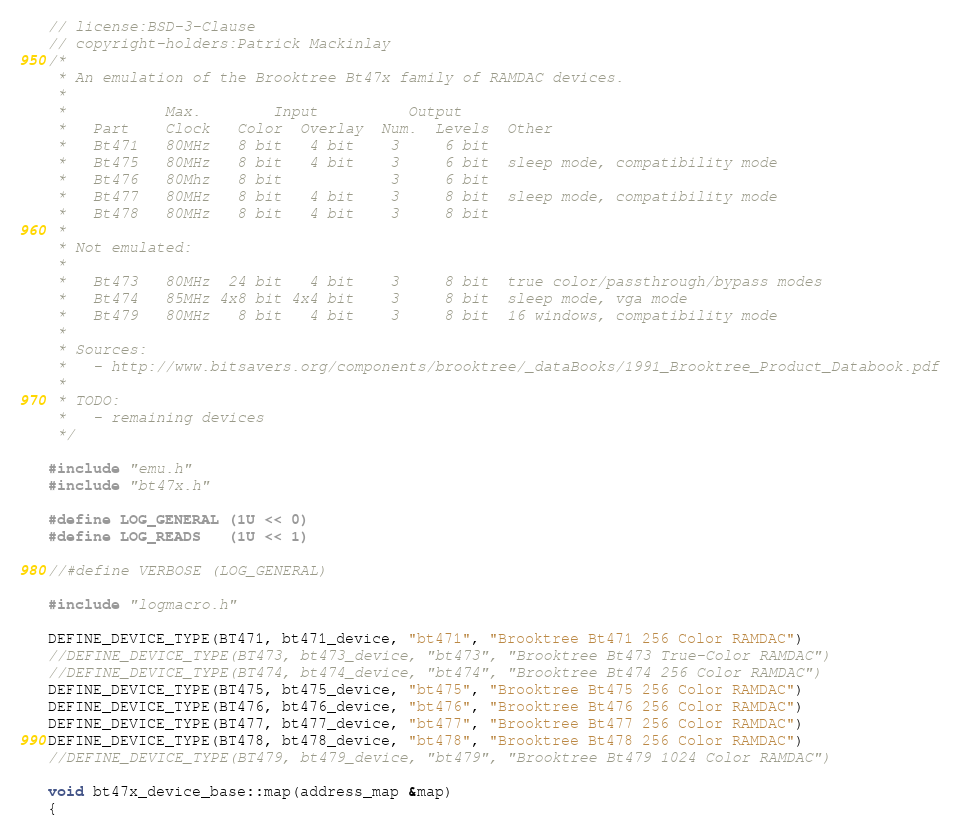<code> <loc_0><loc_0><loc_500><loc_500><_C++_>// license:BSD-3-Clause
// copyright-holders:Patrick Mackinlay
/*
 * An emulation of the Brooktree Bt47x family of RAMDAC devices.
 *
 *           Max.        Input          Output
 *   Part    Clock   Color  Overlay  Num.  Levels  Other
 *   Bt471   80MHz   8 bit   4 bit    3     6 bit
 *   Bt475   80MHz   8 bit   4 bit    3     6 bit  sleep mode, compatibility mode
 *   Bt476   80Mhz   8 bit            3     6 bit
 *   Bt477   80MHz   8 bit   4 bit    3     8 bit  sleep mode, compatibility mode
 *   Bt478   80MHz   8 bit   4 bit    3     8 bit
 *
 * Not emulated:
 *
 *   Bt473   80MHz  24 bit   4 bit    3     8 bit  true color/passthrough/bypass modes
 *   Bt474   85MHz 4x8 bit 4x4 bit    3     8 bit  sleep mode, vga mode
 *   Bt479   80MHz   8 bit   4 bit    3     8 bit  16 windows, compatibility mode
 *
 * Sources:
 *   - http://www.bitsavers.org/components/brooktree/_dataBooks/1991_Brooktree_Product_Databook.pdf
 *
 * TODO:
 *   - remaining devices
 */

#include "emu.h"
#include "bt47x.h"

#define LOG_GENERAL (1U << 0)
#define LOG_READS   (1U << 1)

//#define VERBOSE (LOG_GENERAL)

#include "logmacro.h"

DEFINE_DEVICE_TYPE(BT471, bt471_device, "bt471", "Brooktree Bt471 256 Color RAMDAC")
//DEFINE_DEVICE_TYPE(BT473, bt473_device, "bt473", "Brooktree Bt473 True-Color RAMDAC")
//DEFINE_DEVICE_TYPE(BT474, bt474_device, "bt474", "Brooktree Bt474 256 Color RAMDAC")
DEFINE_DEVICE_TYPE(BT475, bt475_device, "bt475", "Brooktree Bt475 256 Color RAMDAC")
DEFINE_DEVICE_TYPE(BT476, bt476_device, "bt476", "Brooktree Bt476 256 Color RAMDAC")
DEFINE_DEVICE_TYPE(BT477, bt477_device, "bt477", "Brooktree Bt477 256 Color RAMDAC")
DEFINE_DEVICE_TYPE(BT478, bt478_device, "bt478", "Brooktree Bt478 256 Color RAMDAC")
//DEFINE_DEVICE_TYPE(BT479, bt479_device, "bt479", "Brooktree Bt479 1024 Color RAMDAC")

void bt47x_device_base::map(address_map &map)
{</code> 